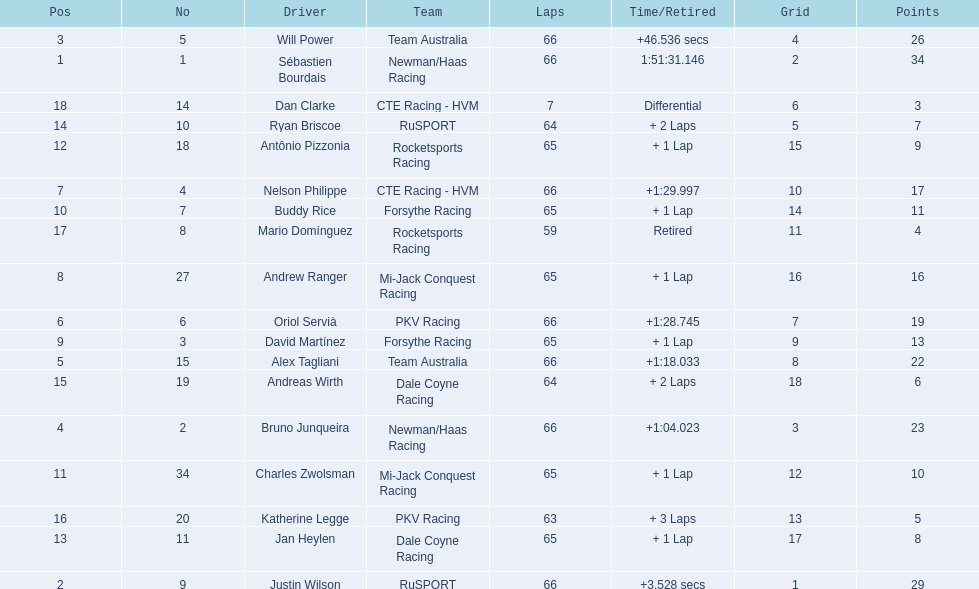Who are all the drivers? Sébastien Bourdais, Justin Wilson, Will Power, Bruno Junqueira, Alex Tagliani, Oriol Servià, Nelson Philippe, Andrew Ranger, David Martínez, Buddy Rice, Charles Zwolsman, Antônio Pizzonia, Jan Heylen, Ryan Briscoe, Andreas Wirth, Katherine Legge, Mario Domínguez, Dan Clarke. What position did they reach? 1, 2, 3, 4, 5, 6, 7, 8, 9, 10, 11, 12, 13, 14, 15, 16, 17, 18. What is the number for each driver? 1, 9, 5, 2, 15, 6, 4, 27, 3, 7, 34, 18, 11, 10, 19, 20, 8, 14. And which player's number and position match? Sébastien Bourdais. 